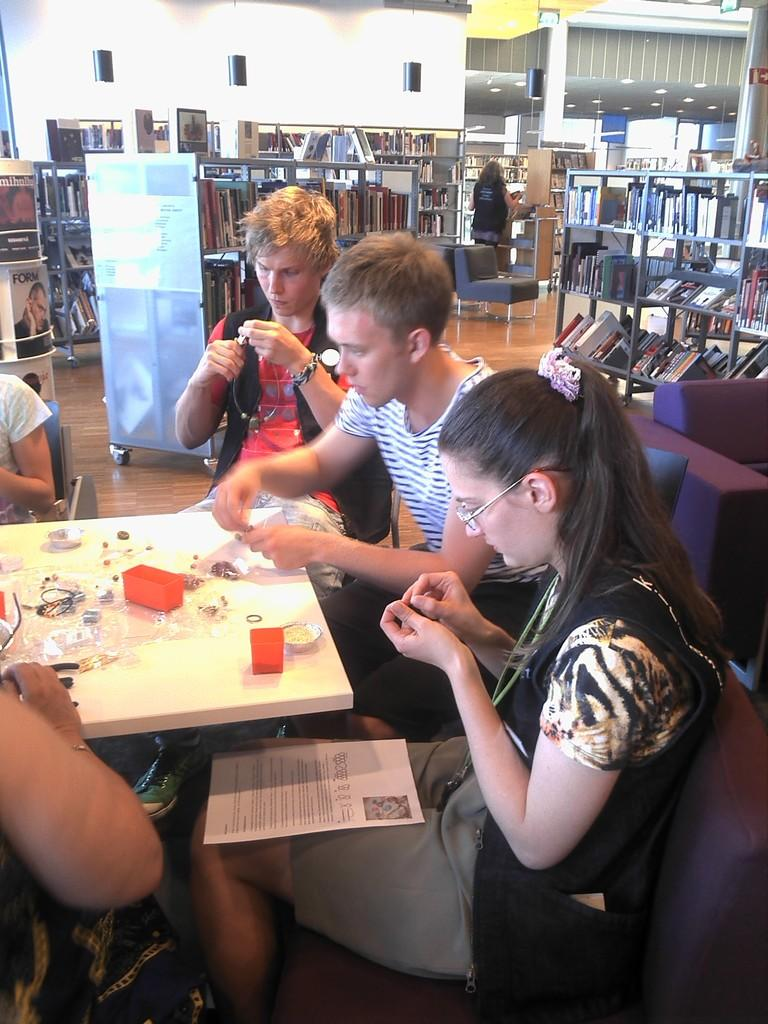What are the people in the image doing? The people in the image are sitting on chairs at a table. What objects can be seen on the table? There are boxes on the table. What can be seen in the background of the image? There is a wall, a bookshelf with books, and a light in the background. What type of straw is being used to build a tramp in the image? There is no straw or tramp present in the image. The image features people sitting at a table with boxes and a background containing a wall, bookshelf, and light. 